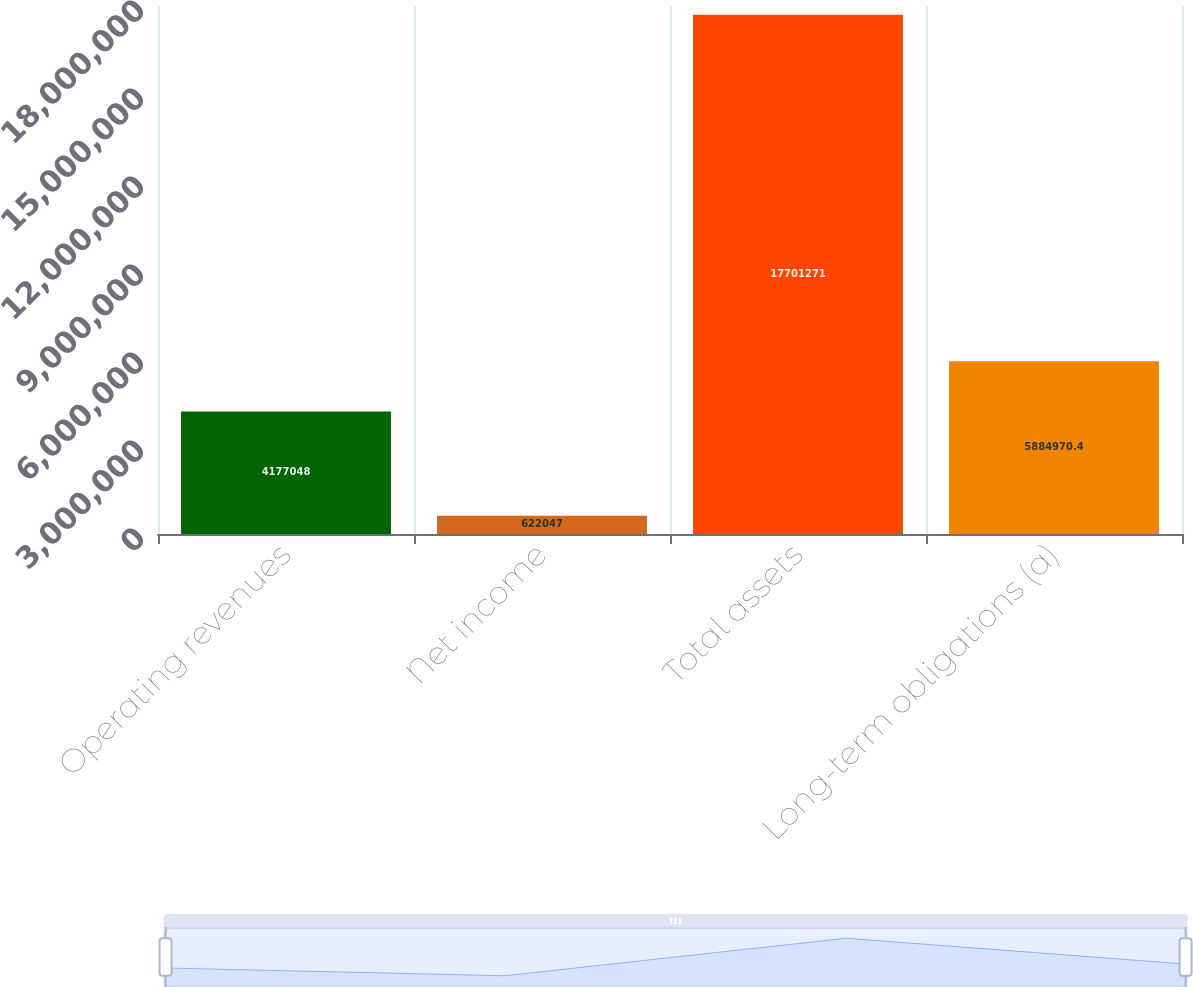Convert chart to OTSL. <chart><loc_0><loc_0><loc_500><loc_500><bar_chart><fcel>Operating revenues<fcel>Net income<fcel>Total assets<fcel>Long-term obligations (a)<nl><fcel>4.17705e+06<fcel>622047<fcel>1.77013e+07<fcel>5.88497e+06<nl></chart> 